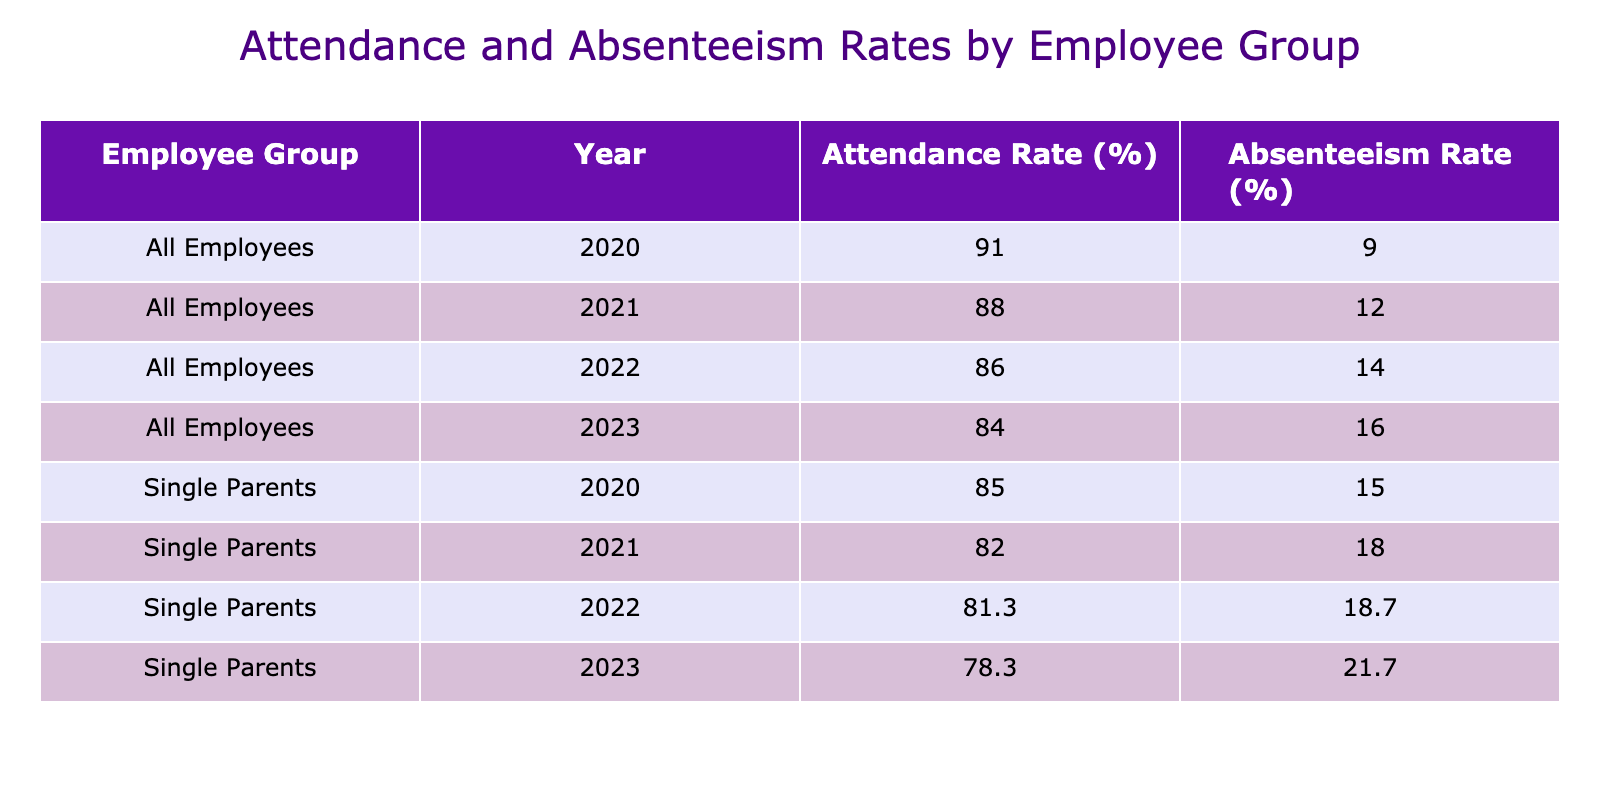What was the highest attendance rate for single parents? The attendance rates for single parents are listed for each year. By comparing the rates, 85% in 2020 is the highest value.
Answer: 85% What is the absenteeism rate for all employees in 2022? The absenteeism rate for all employees in 2022 is listed in the table as 14%.
Answer: 14% How many years did single parents have an attendance rate below 80%? The attendance rates below 80% for single parents occurred in 2022 (80%) and 2023 (78%). This counts as two years.
Answer: 2 Which employee group had the lowest attendance rate in 2023? By looking at the attendance rates for 2023, single parents have an attendance rate of 78%, which is lower than all employees at 85%.
Answer: Single Parents What is the difference in absenteeism rates between single parents and all employees in 2021? The absenteeism rate for single parents in 2021 is 18% and for all employees is 12%. The difference is calculated by subtracting 12% from 18%, which equals 6%.
Answer: 6% Did the attendance rate for single parents increase or decrease from 2021 to 2022? The attendance rate for single parents decreased from 82% in 2021 to 80% in 2022, indicating a decline.
Answer: Decrease What is the average absenteeism rate for all employees from 2020 to 2023? We take the absenteeism rates for all employees: 10%, 12%, 14%, and 15%. Summing these gives us 51%, and dividing by 4 gives an average of 12.75%.
Answer: 12.75% What trend is observed in the absenteeism rates of single parents from 2020 to 2023? The absenteeism rates for single parents are increasing each year: 15% in 2020, 18% in 2021, 20% in 2022, and 22% in 2023. This shows a consistent upward trend.
Answer: Increasing What was the highest absenteeism rate for all employees from 2020 to 2023? The highest absenteeism rate in the specified range is 16% in 2023. Looking at the rates over the years, 16% is greater than all previous values.
Answer: 16% Which year had the highest absenteeism rate for single parents, and what was that rate? The year with the highest absenteeism rate for single parents is 2023, where the rate is 22%. Looking at the rates, 22% is the maximum recorded.
Answer: 2023, 22% 